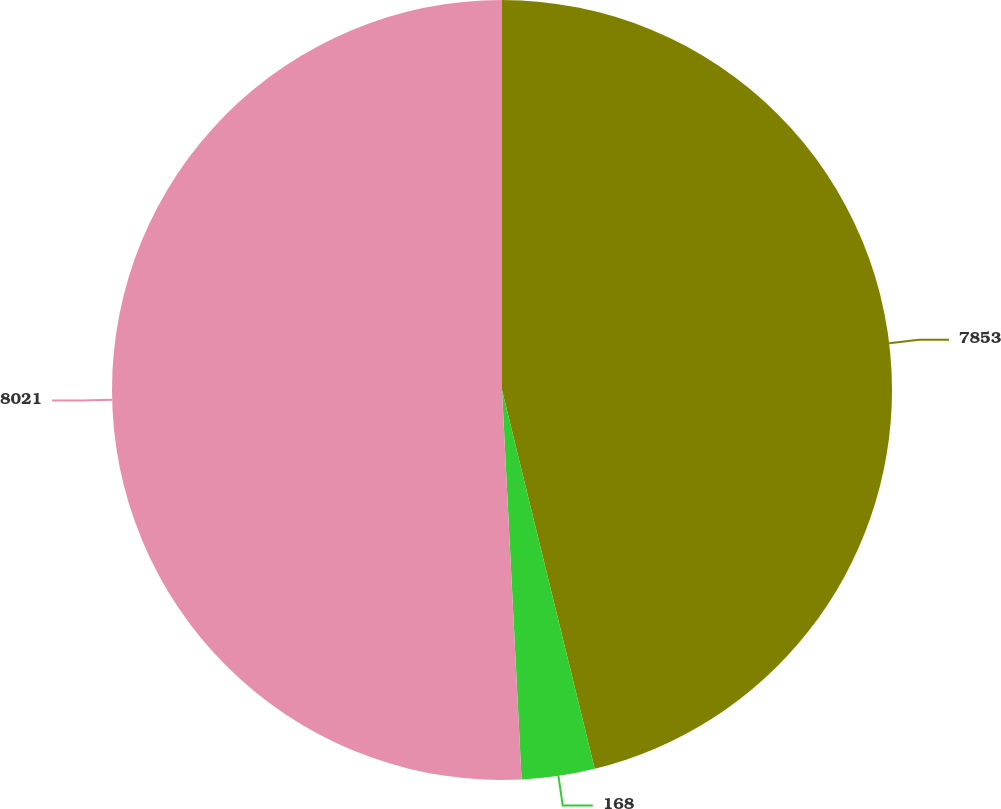<chart> <loc_0><loc_0><loc_500><loc_500><pie_chart><fcel>7853<fcel>168<fcel>8021<nl><fcel>46.18%<fcel>3.02%<fcel>50.8%<nl></chart> 